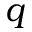<formula> <loc_0><loc_0><loc_500><loc_500>q</formula> 